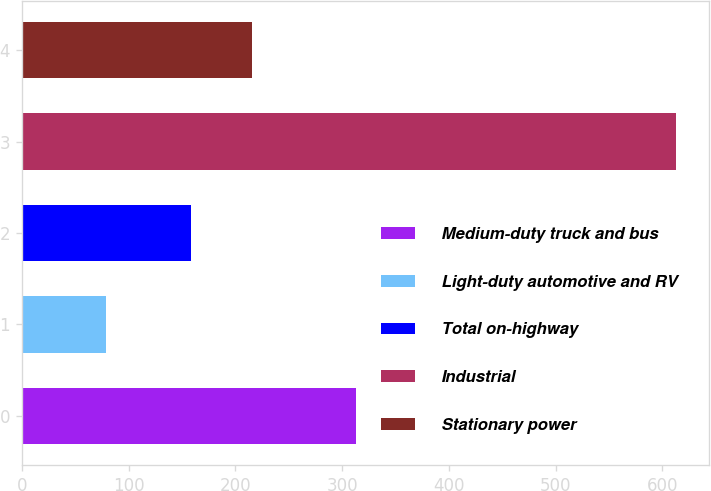<chart> <loc_0><loc_0><loc_500><loc_500><bar_chart><fcel>Medium-duty truck and bus<fcel>Light-duty automotive and RV<fcel>Total on-highway<fcel>Industrial<fcel>Stationary power<nl><fcel>313<fcel>79<fcel>158<fcel>613<fcel>216<nl></chart> 